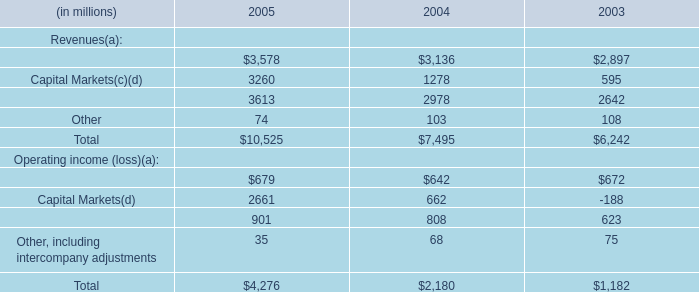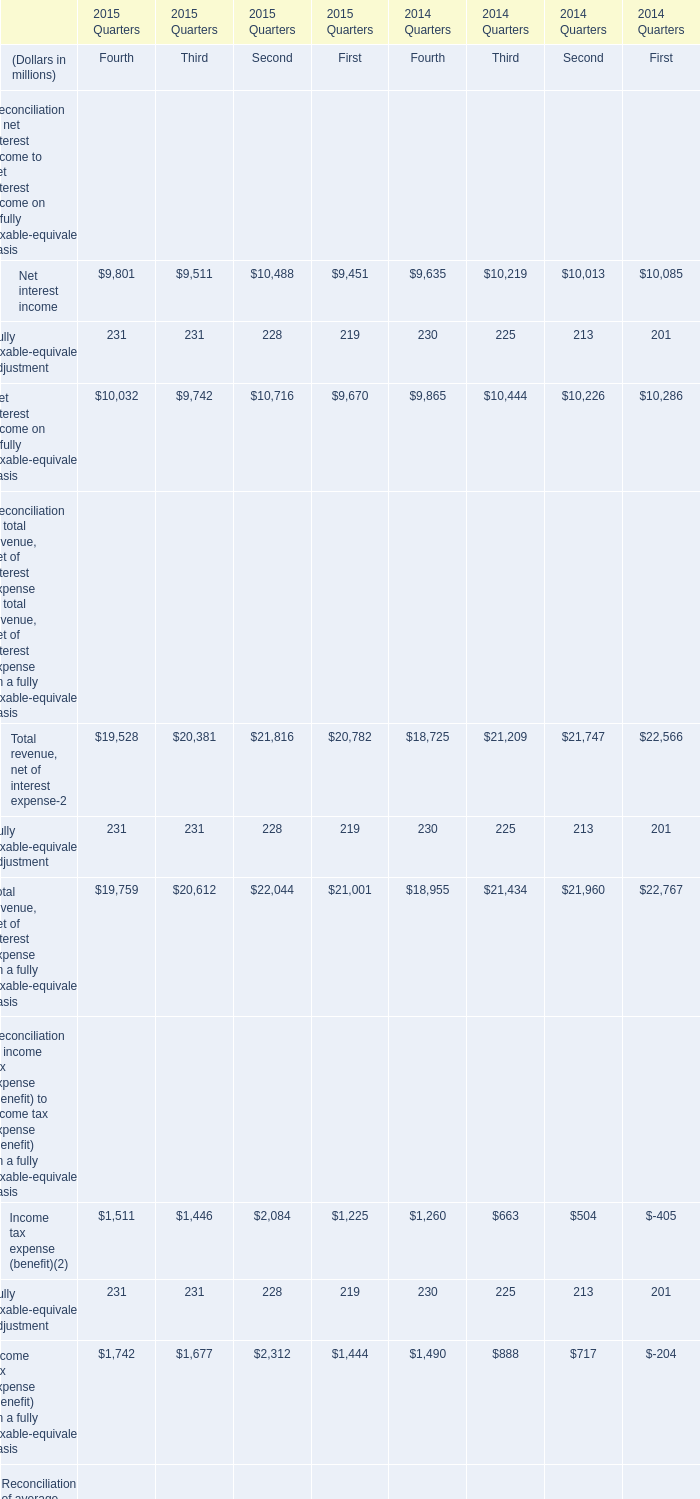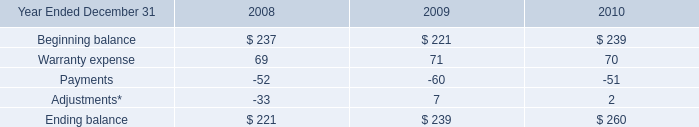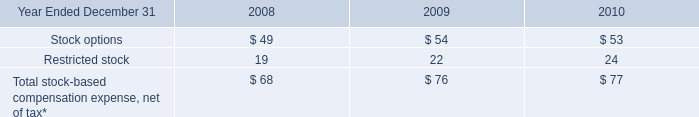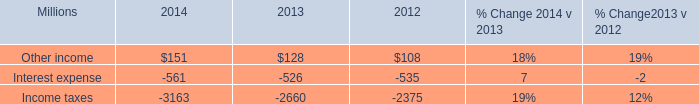In the year with largest amount of Net interest income, what's the increasing rate of Net interest income on a fully taxable-equivalent basis? 
Computations: (((((10032 + 9742) + 10716) + 9670) - (((9865 + 10444) + 10226) + 10286)) / (((9865 + 10444) + 10226) + 10286))
Answer: -0.01619. 